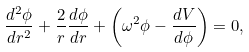<formula> <loc_0><loc_0><loc_500><loc_500>\frac { d ^ { 2 } \phi } { d r ^ { 2 } } + \frac { 2 } { r } \frac { d \phi } { d r } + \left ( \omega ^ { 2 } \phi - \frac { d V } { d \phi } \right ) = 0 ,</formula> 